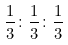Convert formula to latex. <formula><loc_0><loc_0><loc_500><loc_500>\frac { 1 } { 3 } \colon \frac { 1 } { 3 } \colon \frac { 1 } { 3 }</formula> 